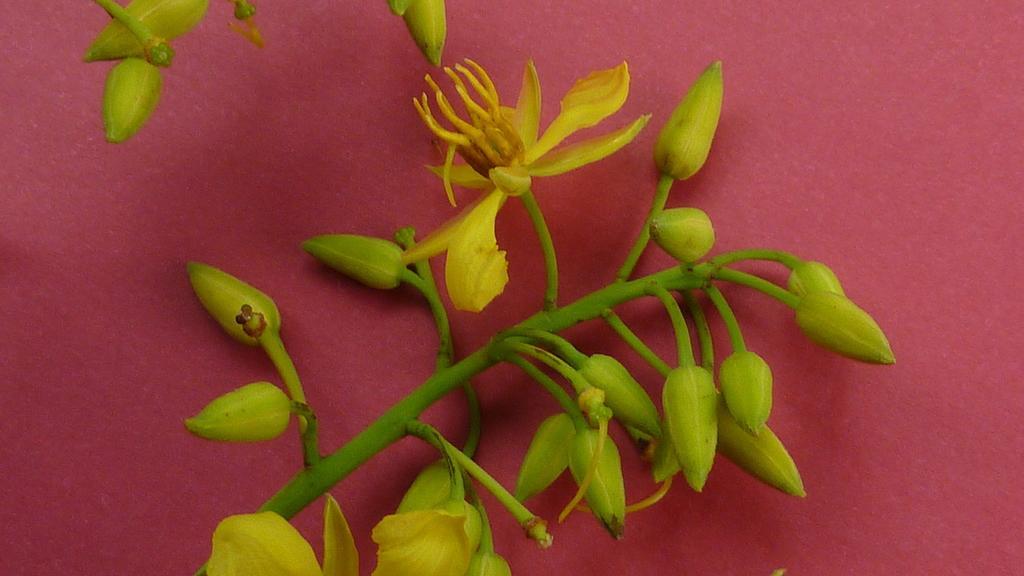How would you summarize this image in a sentence or two? In this image there is a plant having few flowers and buds is kept on the surface which is in red color. Top of the image there is are few buds to the stem. 